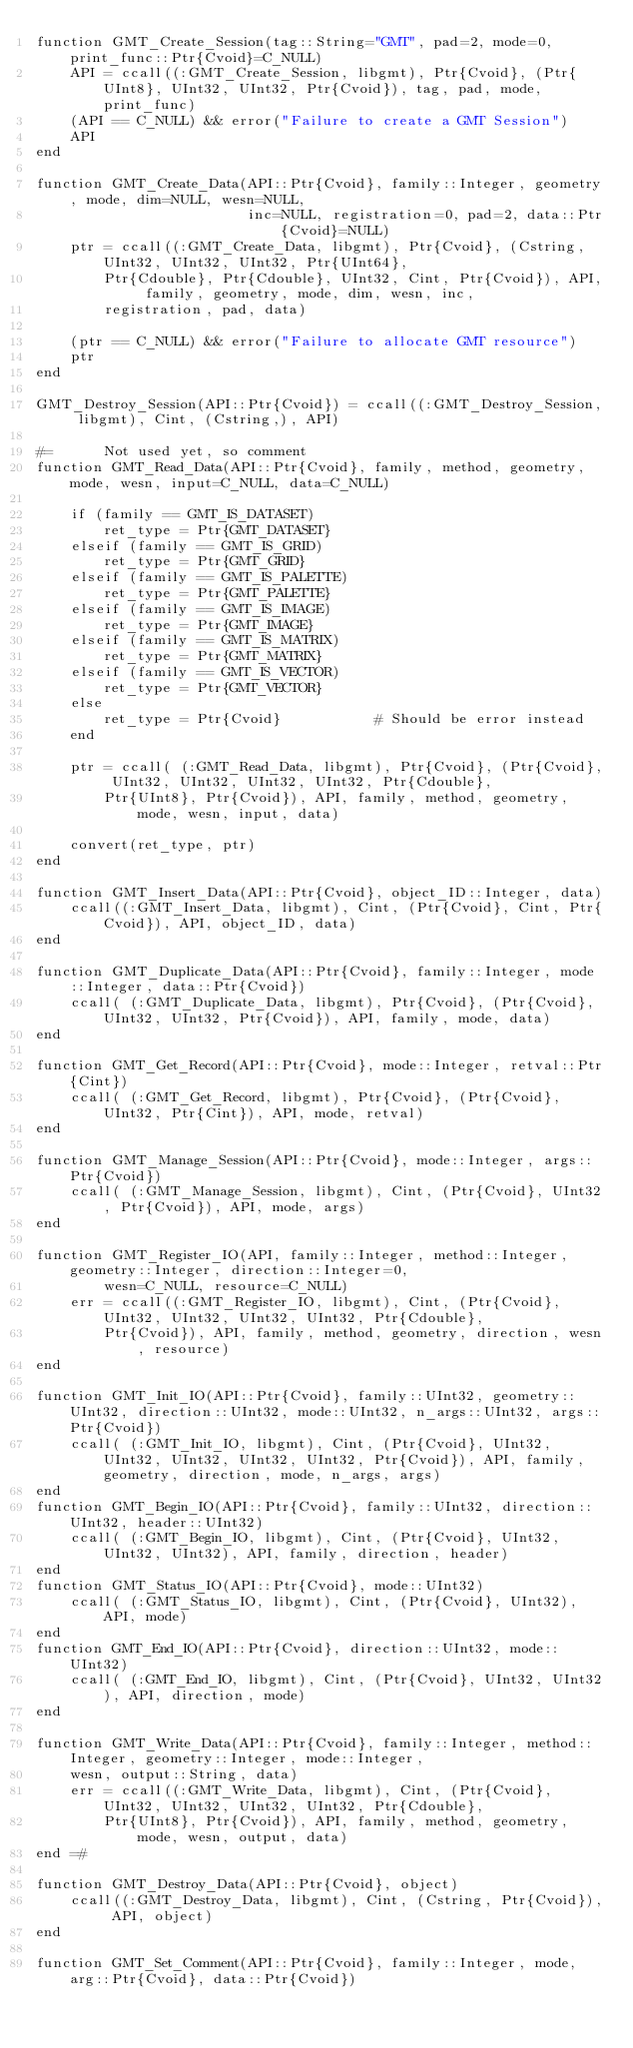<code> <loc_0><loc_0><loc_500><loc_500><_Julia_>function GMT_Create_Session(tag::String="GMT", pad=2, mode=0, print_func::Ptr{Cvoid}=C_NULL)
	API = ccall((:GMT_Create_Session, libgmt), Ptr{Cvoid}, (Ptr{UInt8}, UInt32, UInt32, Ptr{Cvoid}), tag, pad, mode, print_func)
	(API == C_NULL) && error("Failure to create a GMT Session")
	API
end

function GMT_Create_Data(API::Ptr{Cvoid}, family::Integer, geometry, mode, dim=NULL, wesn=NULL,
                         inc=NULL, registration=0, pad=2, data::Ptr{Cvoid}=NULL)
	ptr = ccall((:GMT_Create_Data, libgmt), Ptr{Cvoid}, (Cstring, UInt32, UInt32, UInt32, Ptr{UInt64},
		Ptr{Cdouble}, Ptr{Cdouble}, UInt32, Cint, Ptr{Cvoid}), API, family, geometry, mode, dim, wesn, inc,
		registration, pad, data)

	(ptr == C_NULL) && error("Failure to allocate GMT resource")
	ptr
end

GMT_Destroy_Session(API::Ptr{Cvoid}) = ccall((:GMT_Destroy_Session, libgmt), Cint, (Cstring,), API)

#=		Not used yet, so comment
function GMT_Read_Data(API::Ptr{Cvoid}, family, method, geometry, mode, wesn, input=C_NULL, data=C_NULL)

	if (family == GMT_IS_DATASET)
		ret_type = Ptr{GMT_DATASET}
	elseif (family == GMT_IS_GRID)
		ret_type = Ptr{GMT_GRID}
	elseif (family == GMT_IS_PALETTE)
		ret_type = Ptr{GMT_PALETTE}
	elseif (family == GMT_IS_IMAGE)
		ret_type = Ptr{GMT_IMAGE}
	elseif (family == GMT_IS_MATRIX)
		ret_type = Ptr{GMT_MATRIX}
	elseif (family == GMT_IS_VECTOR)
		ret_type = Ptr{GMT_VECTOR}
	else
		ret_type = Ptr{Cvoid}			# Should be error instead
	end

	ptr = ccall( (:GMT_Read_Data, libgmt), Ptr{Cvoid}, (Ptr{Cvoid}, UInt32, UInt32, UInt32, UInt32, Ptr{Cdouble},
		Ptr{UInt8}, Ptr{Cvoid}), API, family, method, geometry, mode, wesn, input, data)

	convert(ret_type, ptr)
end

function GMT_Insert_Data(API::Ptr{Cvoid}, object_ID::Integer, data)
	ccall((:GMT_Insert_Data, libgmt), Cint, (Ptr{Cvoid}, Cint, Ptr{Cvoid}), API, object_ID, data)
end

function GMT_Duplicate_Data(API::Ptr{Cvoid}, family::Integer, mode::Integer, data::Ptr{Cvoid})
	ccall( (:GMT_Duplicate_Data, libgmt), Ptr{Cvoid}, (Ptr{Cvoid}, UInt32, UInt32, Ptr{Cvoid}), API, family, mode, data)
end

function GMT_Get_Record(API::Ptr{Cvoid}, mode::Integer, retval::Ptr{Cint})
	ccall( (:GMT_Get_Record, libgmt), Ptr{Cvoid}, (Ptr{Cvoid}, UInt32, Ptr{Cint}), API, mode, retval)
end

function GMT_Manage_Session(API::Ptr{Cvoid}, mode::Integer, args::Ptr{Cvoid})
	ccall( (:GMT_Manage_Session, libgmt), Cint, (Ptr{Cvoid}, UInt32, Ptr{Cvoid}), API, mode, args)
end

function GMT_Register_IO(API, family::Integer, method::Integer, geometry::Integer, direction::Integer=0,
		wesn=C_NULL, resource=C_NULL)
	err = ccall((:GMT_Register_IO, libgmt), Cint, (Ptr{Cvoid}, UInt32, UInt32, UInt32, UInt32, Ptr{Cdouble},
		Ptr{Cvoid}), API, family, method, geometry, direction, wesn, resource)
end

function GMT_Init_IO(API::Ptr{Cvoid}, family::UInt32, geometry::UInt32, direction::UInt32, mode::UInt32, n_args::UInt32, args::Ptr{Cvoid})
	ccall( (:GMT_Init_IO, libgmt), Cint, (Ptr{Cvoid}, UInt32, UInt32, UInt32, UInt32, UInt32, Ptr{Cvoid}), API, family, geometry, direction, mode, n_args, args)
end
function GMT_Begin_IO(API::Ptr{Cvoid}, family::UInt32, direction::UInt32, header::UInt32)
	ccall( (:GMT_Begin_IO, libgmt), Cint, (Ptr{Cvoid}, UInt32, UInt32, UInt32), API, family, direction, header)
end
function GMT_Status_IO(API::Ptr{Cvoid}, mode::UInt32)
	ccall( (:GMT_Status_IO, libgmt), Cint, (Ptr{Cvoid}, UInt32), API, mode)
end
function GMT_End_IO(API::Ptr{Cvoid}, direction::UInt32, mode::UInt32)
	ccall( (:GMT_End_IO, libgmt), Cint, (Ptr{Cvoid}, UInt32, UInt32), API, direction, mode)
end

function GMT_Write_Data(API::Ptr{Cvoid}, family::Integer, method::Integer, geometry::Integer, mode::Integer,
	wesn, output::String, data)
	err = ccall((:GMT_Write_Data, libgmt), Cint, (Ptr{Cvoid}, UInt32, UInt32, UInt32, UInt32, Ptr{Cdouble},
		Ptr{UInt8}, Ptr{Cvoid}), API, family, method, geometry, mode, wesn, output, data)
end =#

function GMT_Destroy_Data(API::Ptr{Cvoid}, object)
	ccall((:GMT_Destroy_Data, libgmt), Cint, (Cstring, Ptr{Cvoid}), API, object)
end

function GMT_Set_Comment(API::Ptr{Cvoid}, family::Integer, mode, arg::Ptr{Cvoid}, data::Ptr{Cvoid})</code> 